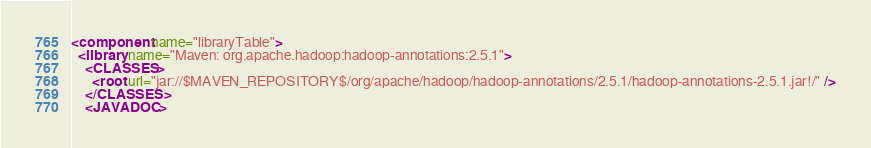<code> <loc_0><loc_0><loc_500><loc_500><_XML_><component name="libraryTable">
  <library name="Maven: org.apache.hadoop:hadoop-annotations:2.5.1">
    <CLASSES>
      <root url="jar://$MAVEN_REPOSITORY$/org/apache/hadoop/hadoop-annotations/2.5.1/hadoop-annotations-2.5.1.jar!/" />
    </CLASSES>
    <JAVADOC></code> 